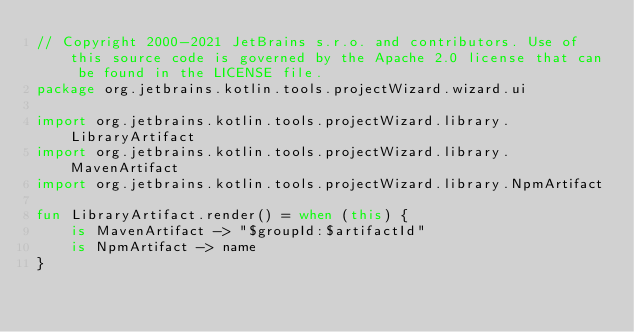<code> <loc_0><loc_0><loc_500><loc_500><_Kotlin_>// Copyright 2000-2021 JetBrains s.r.o. and contributors. Use of this source code is governed by the Apache 2.0 license that can be found in the LICENSE file.
package org.jetbrains.kotlin.tools.projectWizard.wizard.ui

import org.jetbrains.kotlin.tools.projectWizard.library.LibraryArtifact
import org.jetbrains.kotlin.tools.projectWizard.library.MavenArtifact
import org.jetbrains.kotlin.tools.projectWizard.library.NpmArtifact

fun LibraryArtifact.render() = when (this) {
    is MavenArtifact -> "$groupId:$artifactId"
    is NpmArtifact -> name
}

</code> 